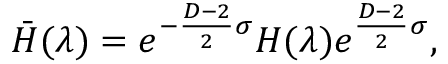Convert formula to latex. <formula><loc_0><loc_0><loc_500><loc_500>\bar { H } ( \lambda ) = e ^ { - { \frac { D - 2 } { 2 } } \sigma } H ( \lambda ) e ^ { { \frac { D - 2 } { 2 } } \sigma } ,</formula> 